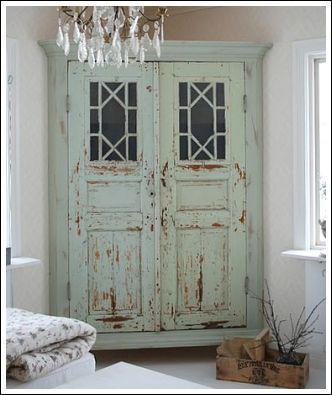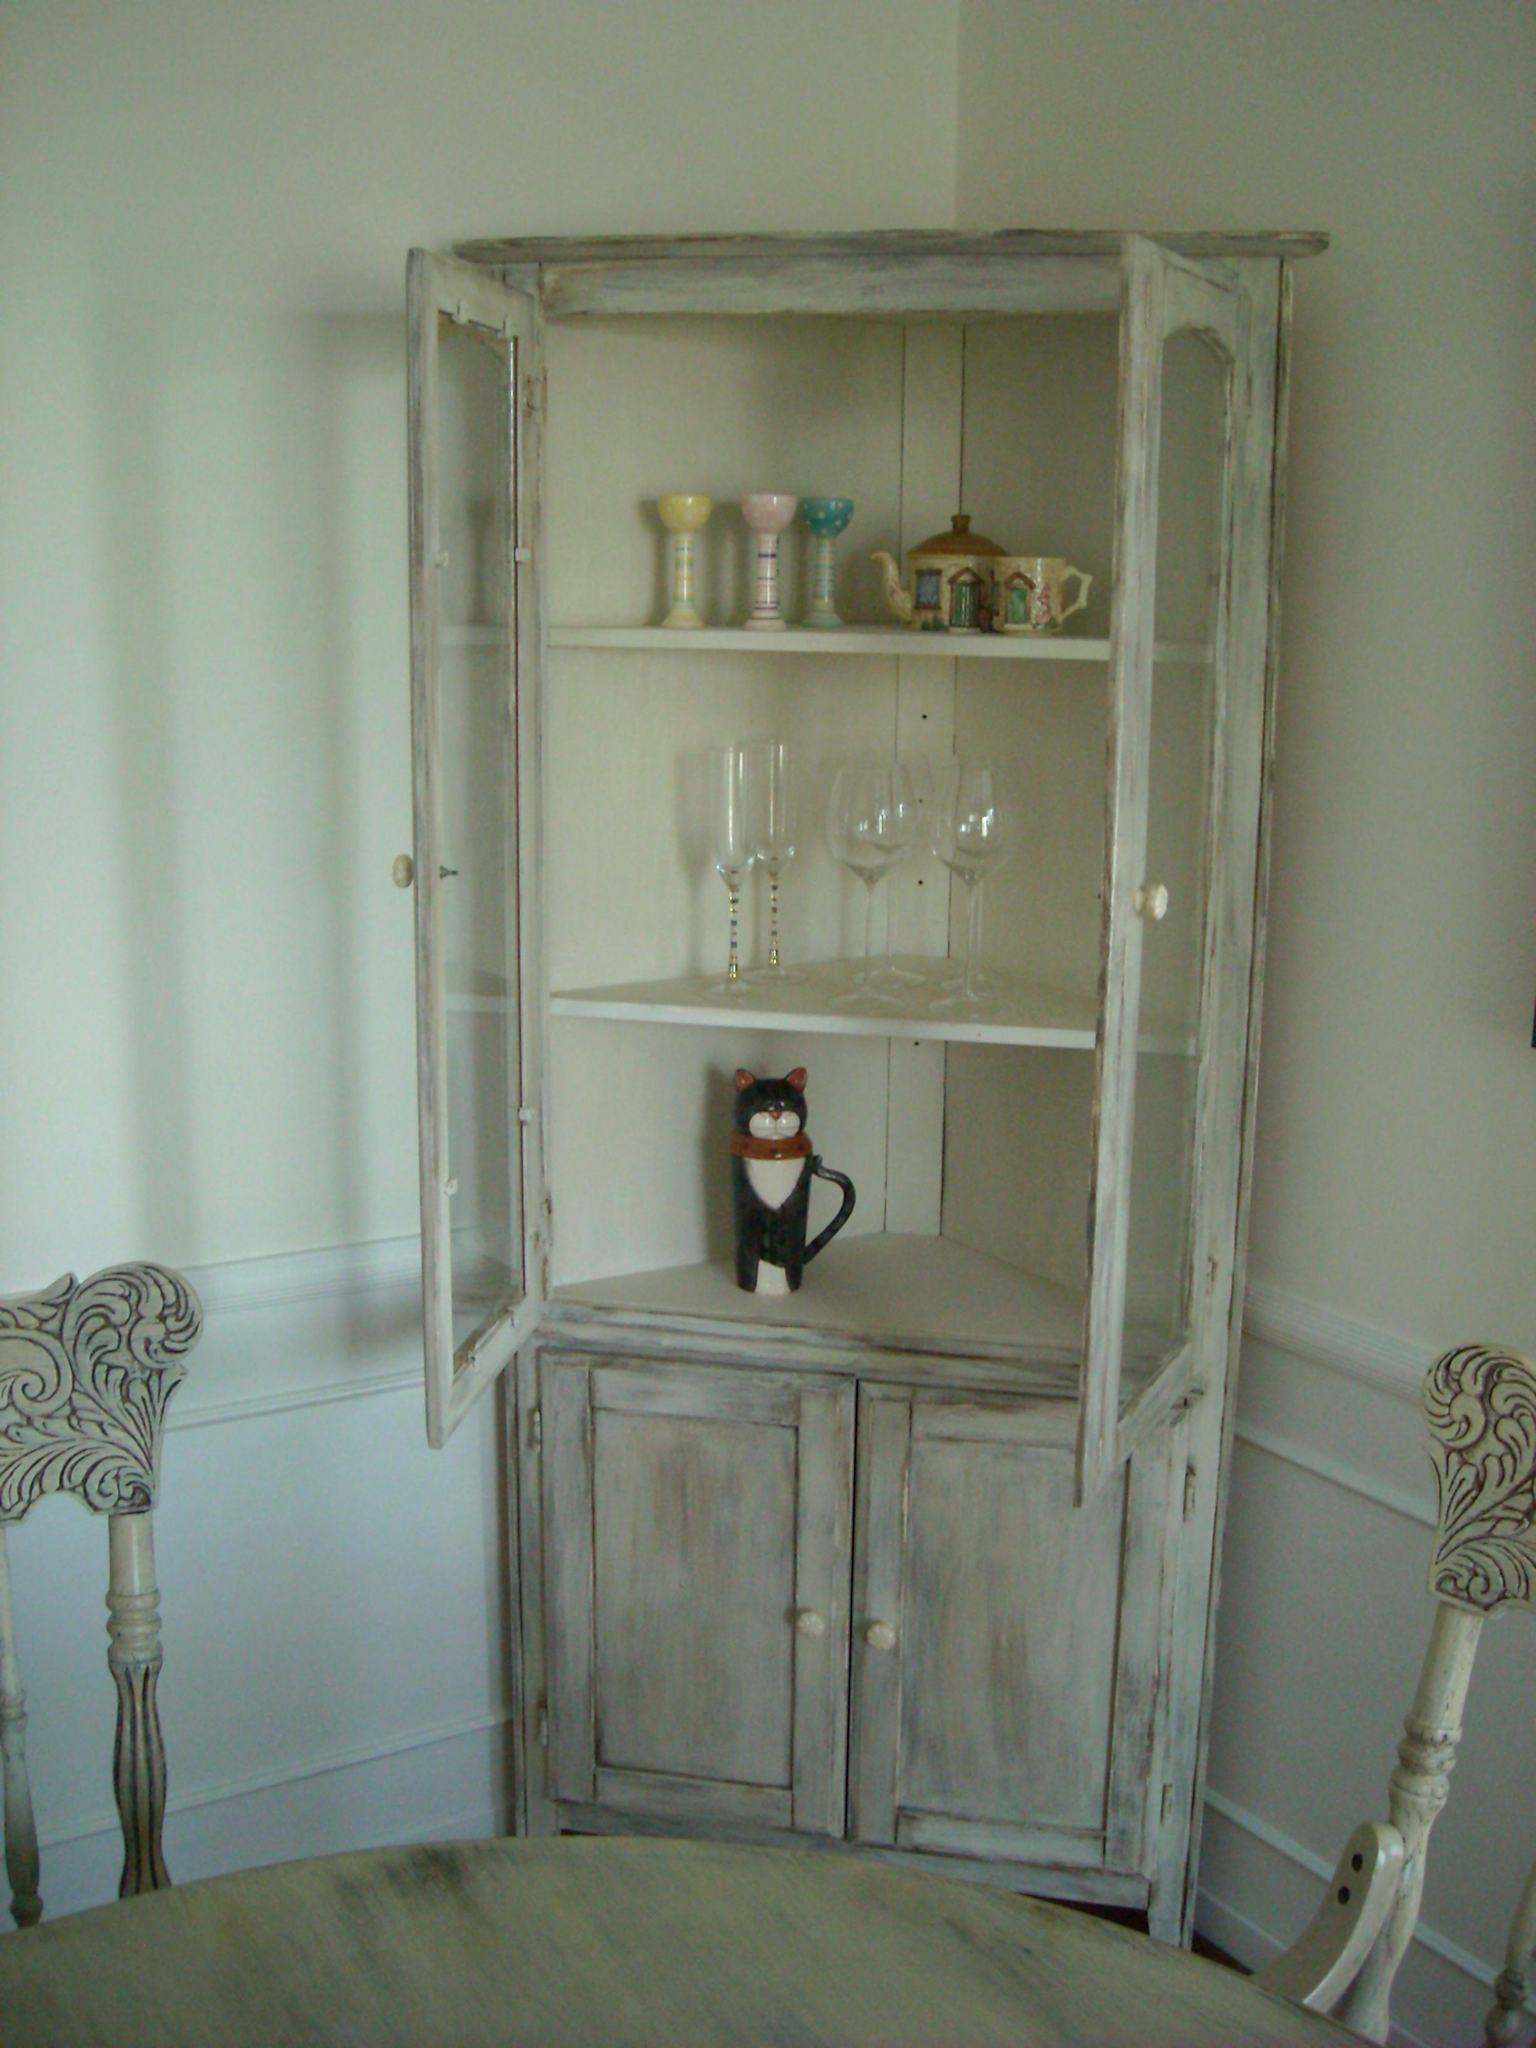The first image is the image on the left, the second image is the image on the right. Given the left and right images, does the statement "There is a flower in a vase." hold true? Answer yes or no. No. 